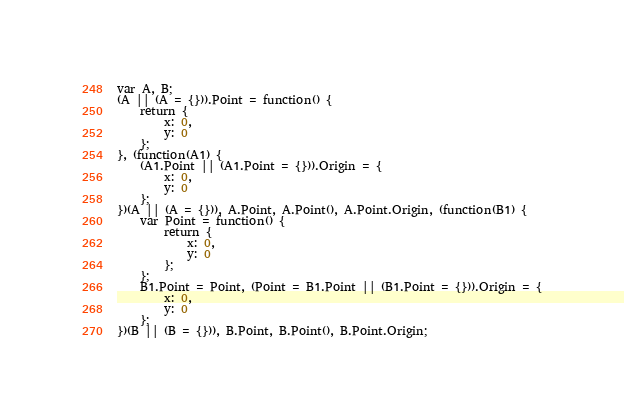<code> <loc_0><loc_0><loc_500><loc_500><_JavaScript_>var A, B;
(A || (A = {})).Point = function() {
    return {
        x: 0,
        y: 0
    };
}, (function(A1) {
    (A1.Point || (A1.Point = {})).Origin = {
        x: 0,
        y: 0
    };
})(A || (A = {})), A.Point, A.Point(), A.Point.Origin, (function(B1) {
    var Point = function() {
        return {
            x: 0,
            y: 0
        };
    };
    B1.Point = Point, (Point = B1.Point || (B1.Point = {})).Origin = {
        x: 0,
        y: 0
    };
})(B || (B = {})), B.Point, B.Point(), B.Point.Origin;
</code> 